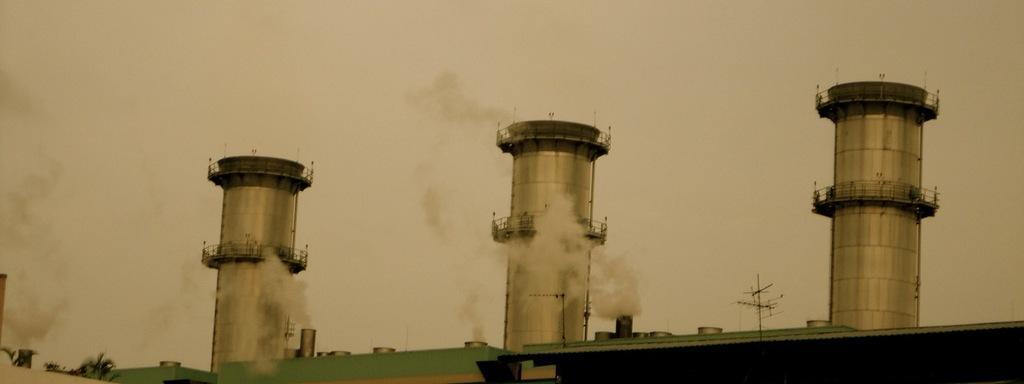How would you summarize this image in a sentence or two? In this image, we can see chimneys and a smoke coming out from it. 